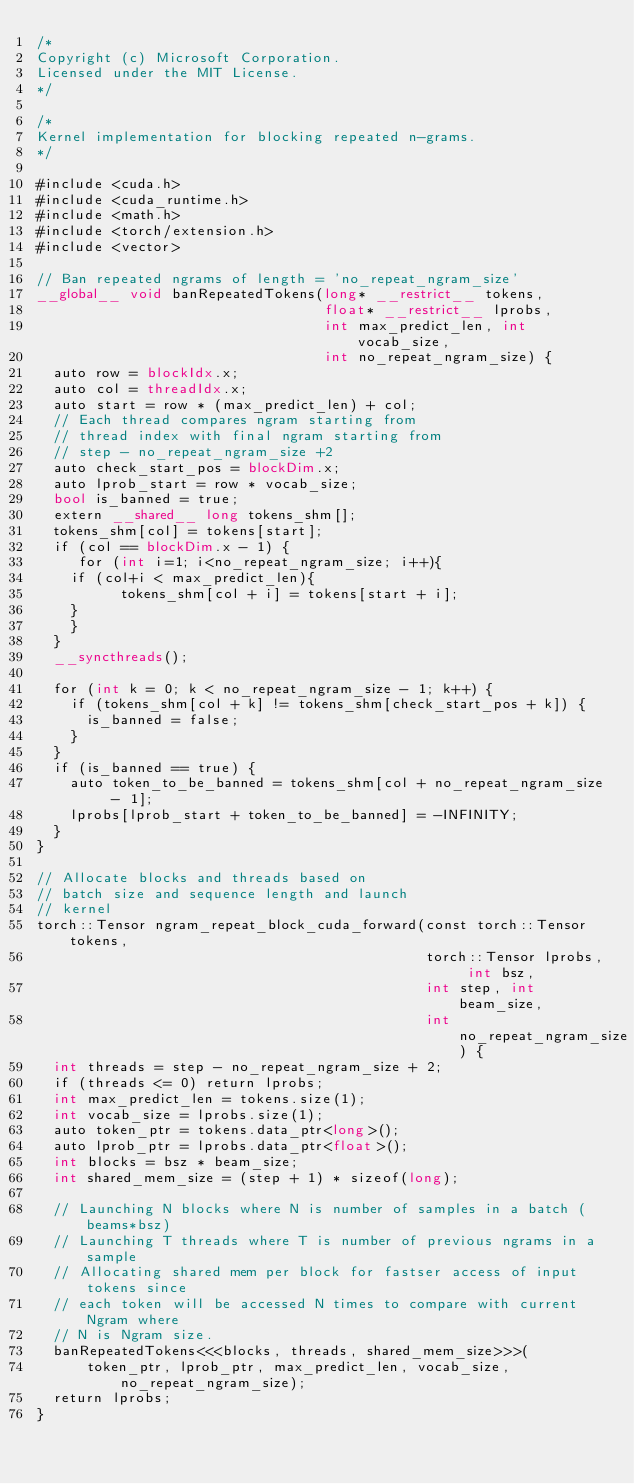<code> <loc_0><loc_0><loc_500><loc_500><_Cuda_>/*
Copyright (c) Microsoft Corporation.
Licensed under the MIT License.
*/

/*
Kernel implementation for blocking repeated n-grams.
*/

#include <cuda.h>
#include <cuda_runtime.h>
#include <math.h>
#include <torch/extension.h>
#include <vector>

// Ban repeated ngrams of length = 'no_repeat_ngram_size'
__global__ void banRepeatedTokens(long* __restrict__ tokens,
                                  float* __restrict__ lprobs,
                                  int max_predict_len, int vocab_size,
                                  int no_repeat_ngram_size) {
  auto row = blockIdx.x;
  auto col = threadIdx.x;
  auto start = row * (max_predict_len) + col;
  // Each thread compares ngram starting from
  // thread index with final ngram starting from
  // step - no_repeat_ngram_size +2
  auto check_start_pos = blockDim.x;
  auto lprob_start = row * vocab_size;
  bool is_banned = true;
  extern __shared__ long tokens_shm[];
  tokens_shm[col] = tokens[start];
  if (col == blockDim.x - 1) {
     for (int i=1; i<no_repeat_ngram_size; i++){
	if (col+i < max_predict_len){
          tokens_shm[col + i] = tokens[start + i];
	}
    }
  }
  __syncthreads();

  for (int k = 0; k < no_repeat_ngram_size - 1; k++) {
    if (tokens_shm[col + k] != tokens_shm[check_start_pos + k]) {
      is_banned = false;
    }
  }
  if (is_banned == true) {
    auto token_to_be_banned = tokens_shm[col + no_repeat_ngram_size - 1];
    lprobs[lprob_start + token_to_be_banned] = -INFINITY;
  }
}

// Allocate blocks and threads based on
// batch size and sequence length and launch
// kernel
torch::Tensor ngram_repeat_block_cuda_forward(const torch::Tensor tokens,
                                              torch::Tensor lprobs, int bsz,
                                              int step, int beam_size,
                                              int no_repeat_ngram_size) {
  int threads = step - no_repeat_ngram_size + 2;
  if (threads <= 0) return lprobs;
  int max_predict_len = tokens.size(1);
  int vocab_size = lprobs.size(1);
  auto token_ptr = tokens.data_ptr<long>();
  auto lprob_ptr = lprobs.data_ptr<float>();
  int blocks = bsz * beam_size;
  int shared_mem_size = (step + 1) * sizeof(long);

  // Launching N blocks where N is number of samples in a batch (beams*bsz)
  // Launching T threads where T is number of previous ngrams in a sample
  // Allocating shared mem per block for fastser access of input tokens since
  // each token will be accessed N times to compare with current Ngram where
  // N is Ngram size.
  banRepeatedTokens<<<blocks, threads, shared_mem_size>>>(
      token_ptr, lprob_ptr, max_predict_len, vocab_size, no_repeat_ngram_size);
  return lprobs;
}
</code> 